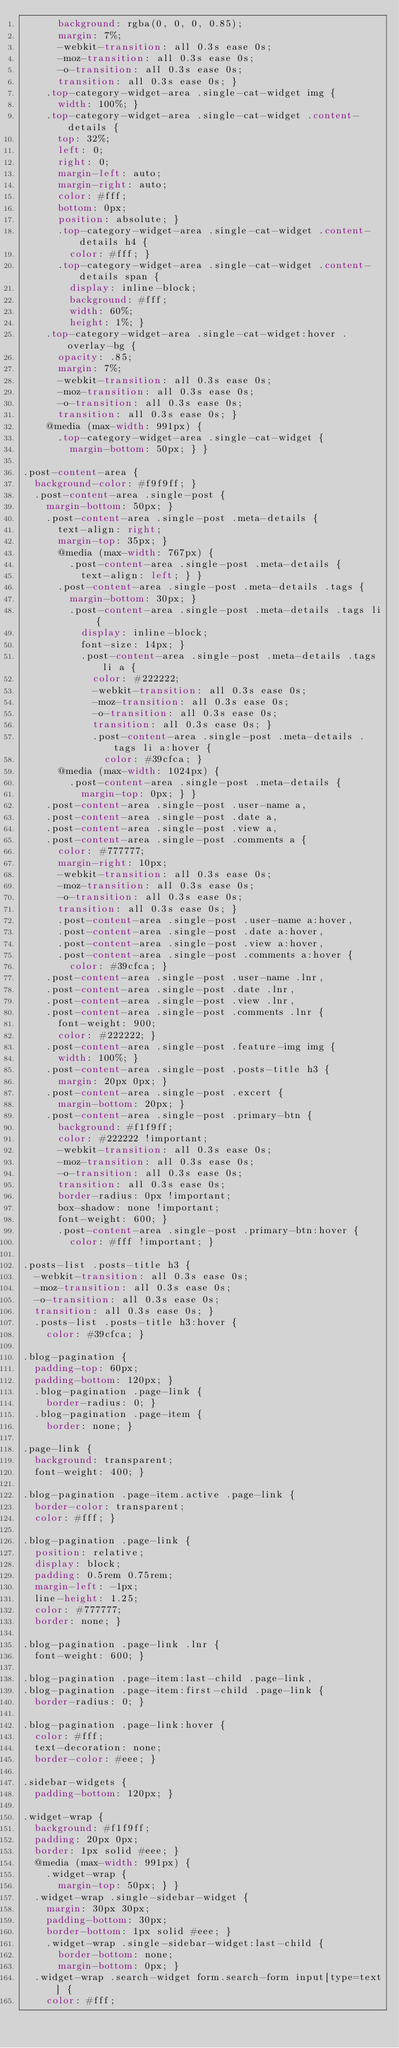<code> <loc_0><loc_0><loc_500><loc_500><_CSS_>      background: rgba(0, 0, 0, 0.85);
      margin: 7%;
      -webkit-transition: all 0.3s ease 0s;
      -moz-transition: all 0.3s ease 0s;
      -o-transition: all 0.3s ease 0s;
      transition: all 0.3s ease 0s; }
    .top-category-widget-area .single-cat-widget img {
      width: 100%; }
    .top-category-widget-area .single-cat-widget .content-details {
      top: 32%;
      left: 0;
      right: 0;
      margin-left: auto;
      margin-right: auto;
      color: #fff;
      bottom: 0px;
      position: absolute; }
      .top-category-widget-area .single-cat-widget .content-details h4 {
        color: #fff; }
      .top-category-widget-area .single-cat-widget .content-details span {
        display: inline-block;
        background: #fff;
        width: 60%;
        height: 1%; }
    .top-category-widget-area .single-cat-widget:hover .overlay-bg {
      opacity: .85;
      margin: 7%;
      -webkit-transition: all 0.3s ease 0s;
      -moz-transition: all 0.3s ease 0s;
      -o-transition: all 0.3s ease 0s;
      transition: all 0.3s ease 0s; }
    @media (max-width: 991px) {
      .top-category-widget-area .single-cat-widget {
        margin-bottom: 50px; } }

.post-content-area {
  background-color: #f9f9ff; }
  .post-content-area .single-post {
    margin-bottom: 50px; }
    .post-content-area .single-post .meta-details {
      text-align: right;
      margin-top: 35px; }
      @media (max-width: 767px) {
        .post-content-area .single-post .meta-details {
          text-align: left; } }
      .post-content-area .single-post .meta-details .tags {
        margin-bottom: 30px; }
        .post-content-area .single-post .meta-details .tags li {
          display: inline-block;
          font-size: 14px; }
          .post-content-area .single-post .meta-details .tags li a {
            color: #222222;
            -webkit-transition: all 0.3s ease 0s;
            -moz-transition: all 0.3s ease 0s;
            -o-transition: all 0.3s ease 0s;
            transition: all 0.3s ease 0s; }
            .post-content-area .single-post .meta-details .tags li a:hover {
              color: #39cfca; }
      @media (max-width: 1024px) {
        .post-content-area .single-post .meta-details {
          margin-top: 0px; } }
    .post-content-area .single-post .user-name a,
    .post-content-area .single-post .date a,
    .post-content-area .single-post .view a,
    .post-content-area .single-post .comments a {
      color: #777777;
      margin-right: 10px;
      -webkit-transition: all 0.3s ease 0s;
      -moz-transition: all 0.3s ease 0s;
      -o-transition: all 0.3s ease 0s;
      transition: all 0.3s ease 0s; }
      .post-content-area .single-post .user-name a:hover,
      .post-content-area .single-post .date a:hover,
      .post-content-area .single-post .view a:hover,
      .post-content-area .single-post .comments a:hover {
        color: #39cfca; }
    .post-content-area .single-post .user-name .lnr,
    .post-content-area .single-post .date .lnr,
    .post-content-area .single-post .view .lnr,
    .post-content-area .single-post .comments .lnr {
      font-weight: 900;
      color: #222222; }
    .post-content-area .single-post .feature-img img {
      width: 100%; }
    .post-content-area .single-post .posts-title h3 {
      margin: 20px 0px; }
    .post-content-area .single-post .excert {
      margin-bottom: 20px; }
    .post-content-area .single-post .primary-btn {
      background: #f1f9ff;
      color: #222222 !important;
      -webkit-transition: all 0.3s ease 0s;
      -moz-transition: all 0.3s ease 0s;
      -o-transition: all 0.3s ease 0s;
      transition: all 0.3s ease 0s;
      border-radius: 0px !important;
      box-shadow: none !important;
      font-weight: 600; }
      .post-content-area .single-post .primary-btn:hover {
        color: #fff !important; }

.posts-list .posts-title h3 {
  -webkit-transition: all 0.3s ease 0s;
  -moz-transition: all 0.3s ease 0s;
  -o-transition: all 0.3s ease 0s;
  transition: all 0.3s ease 0s; }
  .posts-list .posts-title h3:hover {
    color: #39cfca; }

.blog-pagination {
  padding-top: 60px;
  padding-bottom: 120px; }
  .blog-pagination .page-link {
    border-radius: 0; }
  .blog-pagination .page-item {
    border: none; }

.page-link {
  background: transparent;
  font-weight: 400; }

.blog-pagination .page-item.active .page-link {
  border-color: transparent;
  color: #fff; }

.blog-pagination .page-link {
  position: relative;
  display: block;
  padding: 0.5rem 0.75rem;
  margin-left: -1px;
  line-height: 1.25;
  color: #777777;
  border: none; }

.blog-pagination .page-link .lnr {
  font-weight: 600; }

.blog-pagination .page-item:last-child .page-link,
.blog-pagination .page-item:first-child .page-link {
  border-radius: 0; }

.blog-pagination .page-link:hover {
  color: #fff;
  text-decoration: none;
  border-color: #eee; }

.sidebar-widgets {
  padding-bottom: 120px; }

.widget-wrap {
  background: #f1f9ff;
  padding: 20px 0px;
  border: 1px solid #eee; }
  @media (max-width: 991px) {
    .widget-wrap {
      margin-top: 50px; } }
  .widget-wrap .single-sidebar-widget {
    margin: 30px 30px;
    padding-bottom: 30px;
    border-bottom: 1px solid #eee; }
    .widget-wrap .single-sidebar-widget:last-child {
      border-bottom: none;
      margin-bottom: 0px; }
  .widget-wrap .search-widget form.search-form input[type=text] {
    color: #fff;</code> 